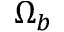Convert formula to latex. <formula><loc_0><loc_0><loc_500><loc_500>\Omega _ { b }</formula> 